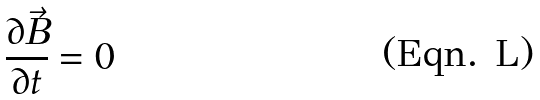<formula> <loc_0><loc_0><loc_500><loc_500>\frac { \partial \vec { B } } { \partial t } = 0</formula> 